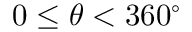<formula> <loc_0><loc_0><loc_500><loc_500>0 \leq \theta < 3 6 0 ^ { \circ }</formula> 